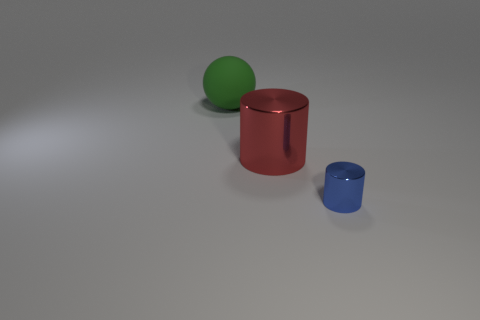The big metallic cylinder is what color?
Provide a succinct answer. Red. What color is the other large shiny thing that is the same shape as the blue shiny thing?
Your answer should be compact. Red. What number of tiny blue objects are the same shape as the big red metal thing?
Offer a terse response. 1. What number of things are large red things or things right of the matte ball?
Your answer should be compact. 2. Do the big sphere and the metal object that is to the left of the tiny object have the same color?
Ensure brevity in your answer.  No. There is a object that is both in front of the large green sphere and behind the small blue metallic cylinder; what is its size?
Your answer should be very brief. Large. There is a rubber sphere; are there any tiny metal things left of it?
Your response must be concise. No. There is a large object in front of the matte sphere; is there a red object behind it?
Ensure brevity in your answer.  No. Is the number of green matte spheres that are on the right side of the big red cylinder the same as the number of big red objects that are in front of the small blue metallic thing?
Offer a terse response. Yes. The small thing that is the same material as the large red object is what color?
Give a very brief answer. Blue. 